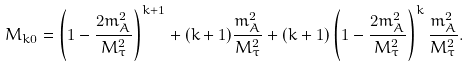<formula> <loc_0><loc_0><loc_500><loc_500>M _ { k 0 } = \left ( 1 - \frac { 2 m _ { A } ^ { 2 } } { M _ { \tau } ^ { 2 } } \right ) ^ { k + 1 } + ( k + 1 ) \frac { m _ { A } ^ { 2 } } { M _ { \tau } ^ { 2 } } + ( k + 1 ) \left ( 1 - \frac { 2 m _ { A } ^ { 2 } } { M _ { \tau } ^ { 2 } } \right ) ^ { k } \frac { m _ { A } ^ { 2 } } { M _ { \tau } ^ { 2 } } .</formula> 